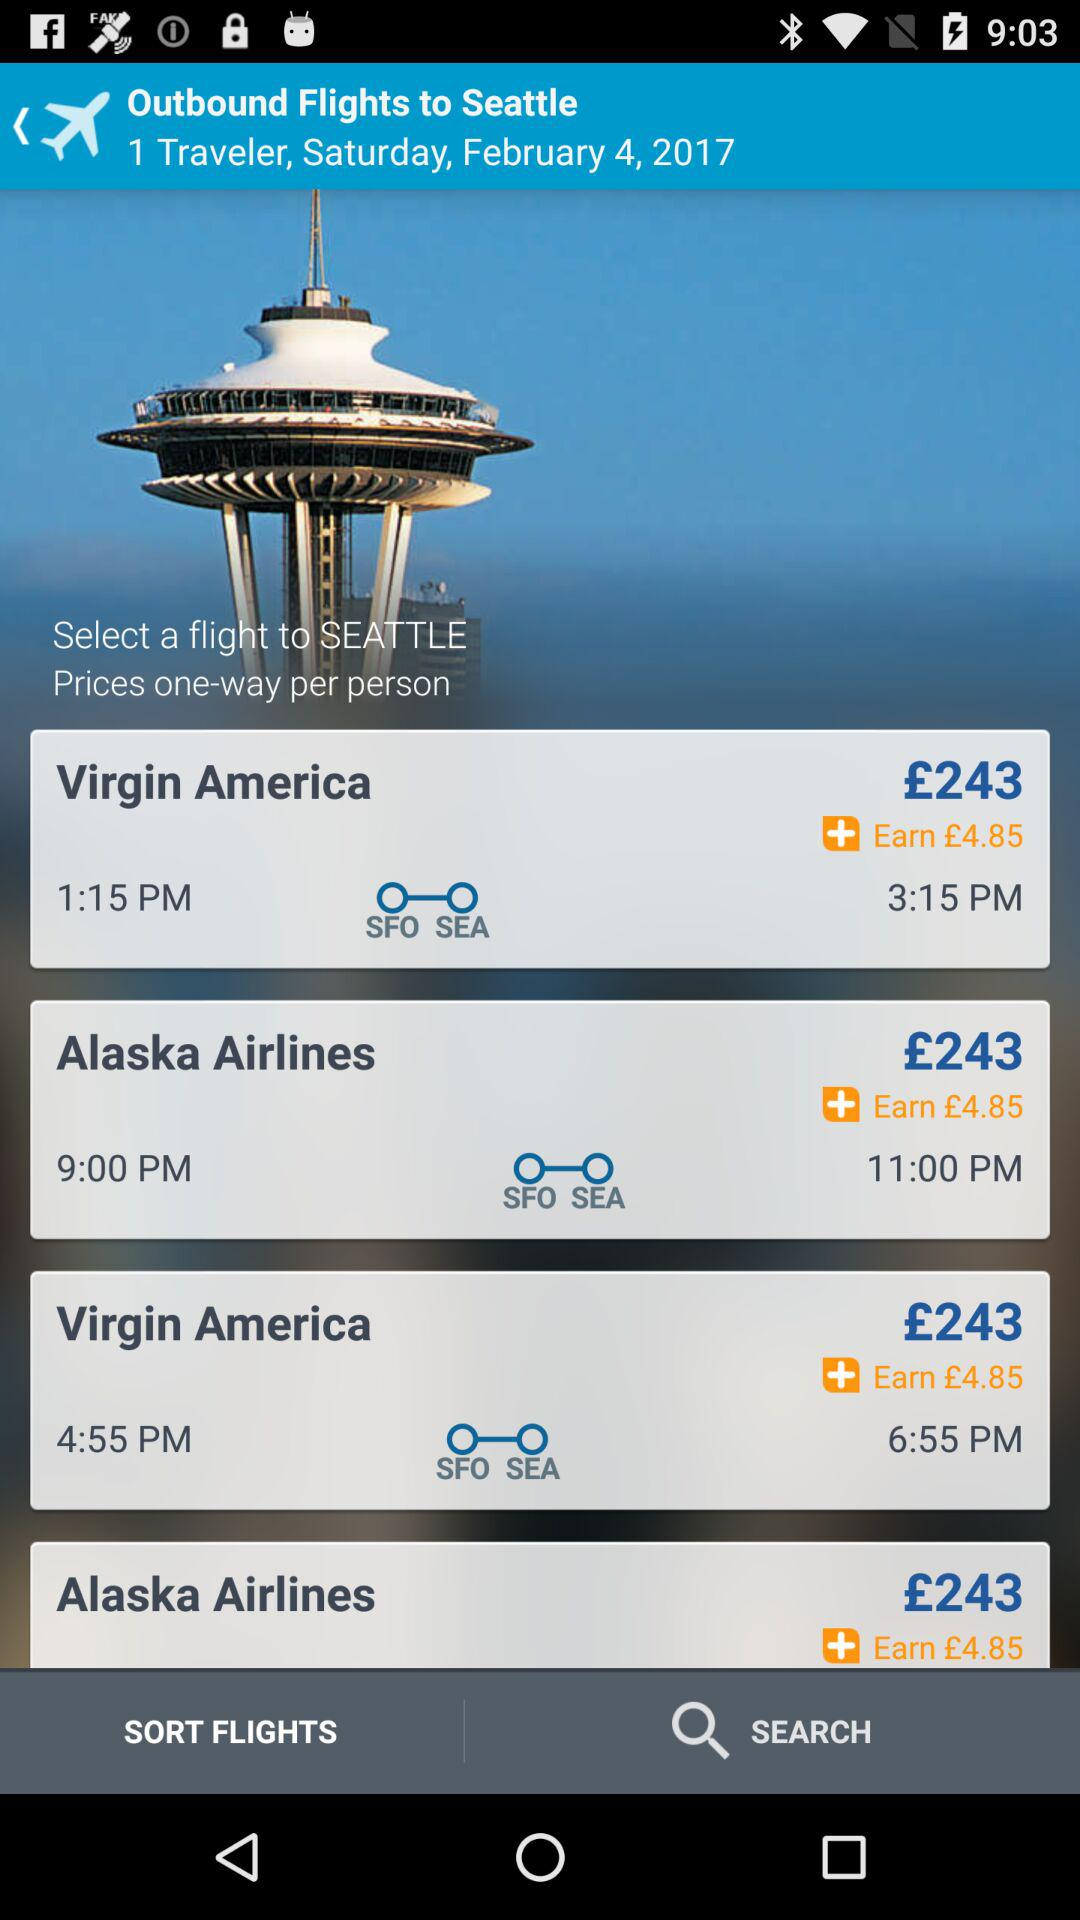What is the ticket price for "Virgin America"? The ticket price is £243. 